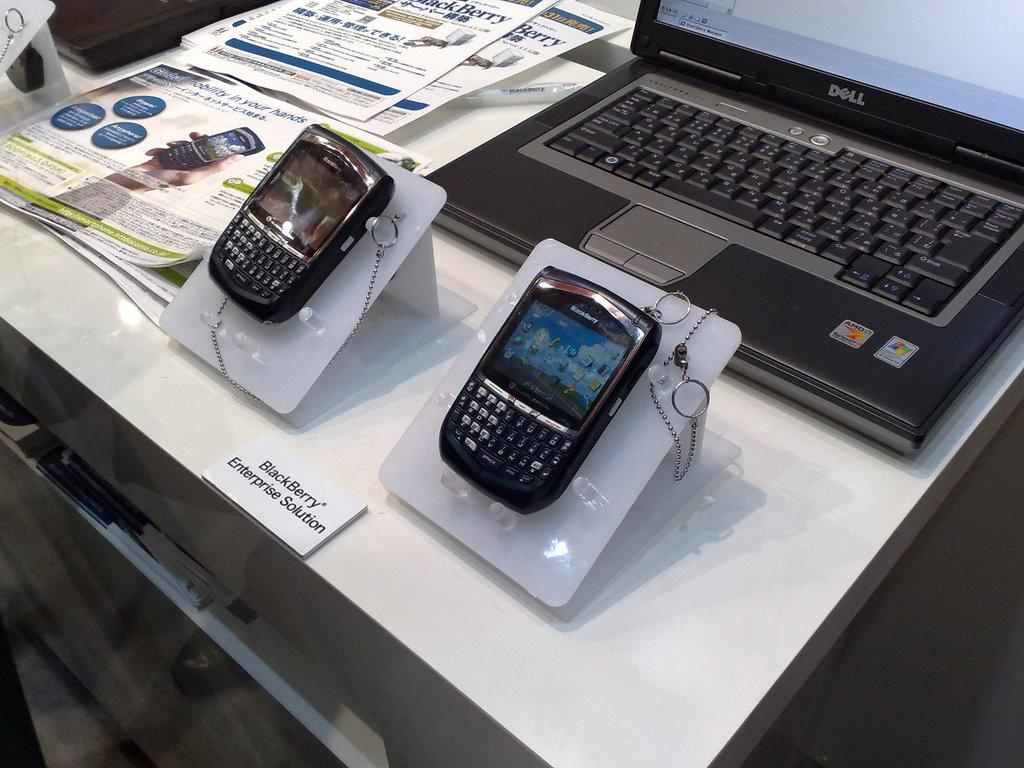What is the brand of the laptop on the table?
Make the answer very short. Dell. What operating system is the laptop running?
Your answer should be very brief. Windows. 